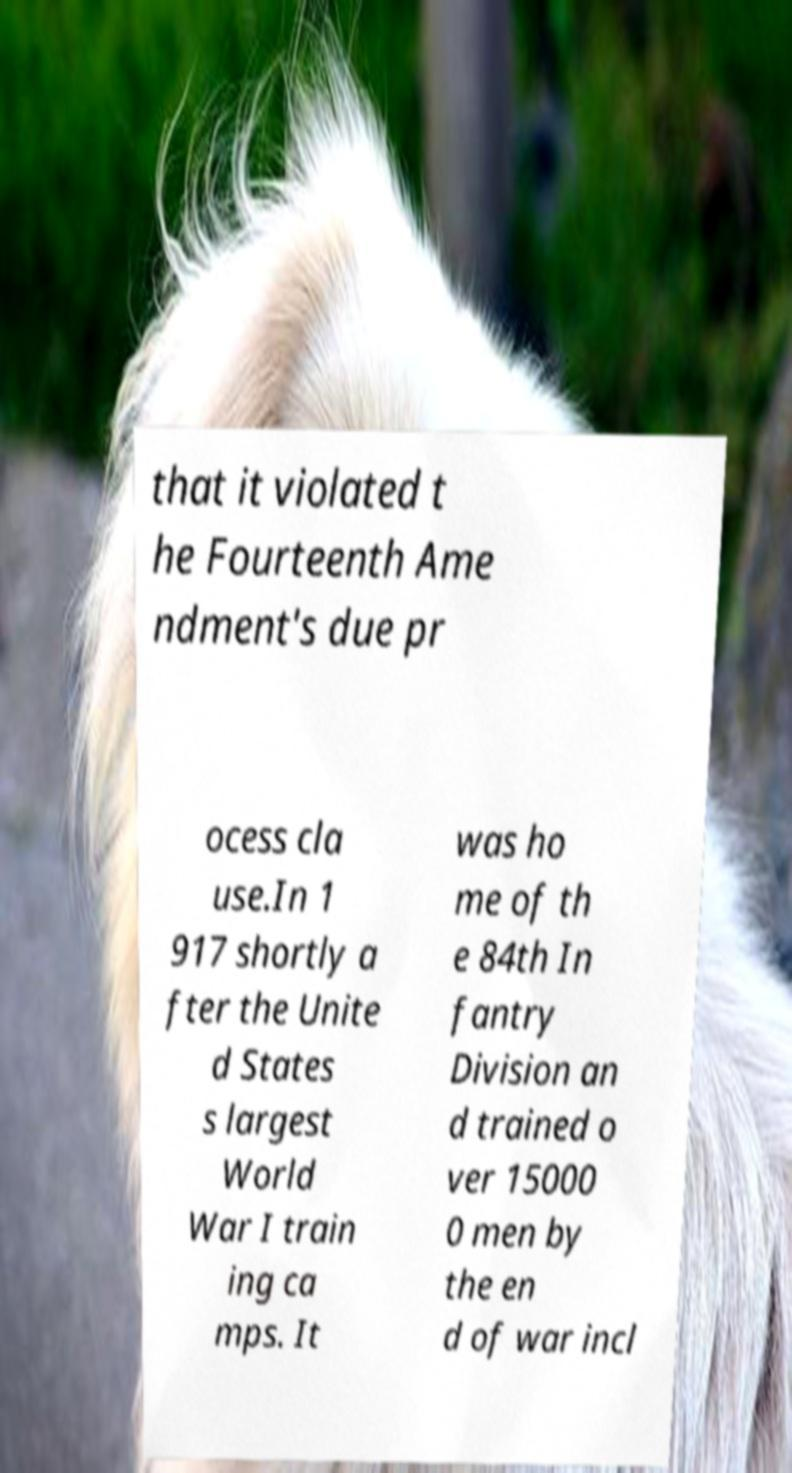Could you assist in decoding the text presented in this image and type it out clearly? that it violated t he Fourteenth Ame ndment's due pr ocess cla use.In 1 917 shortly a fter the Unite d States s largest World War I train ing ca mps. It was ho me of th e 84th In fantry Division an d trained o ver 15000 0 men by the en d of war incl 